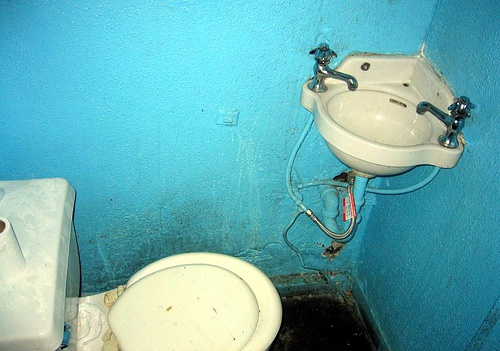Describe the objects in this image and their specific colors. I can see toilet in teal, lightyellow, beige, darkgray, and tan tones and sink in teal, beige, and darkgray tones in this image. 